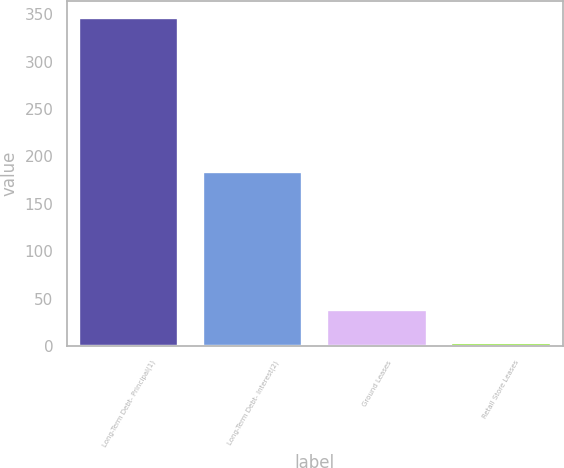Convert chart to OTSL. <chart><loc_0><loc_0><loc_500><loc_500><bar_chart><fcel>Long-Term Debt- Principal(1)<fcel>Long-Term Debt- Interest(2)<fcel>Ground Leases<fcel>Retail Store Leases<nl><fcel>346.5<fcel>183.4<fcel>37.98<fcel>3.7<nl></chart> 